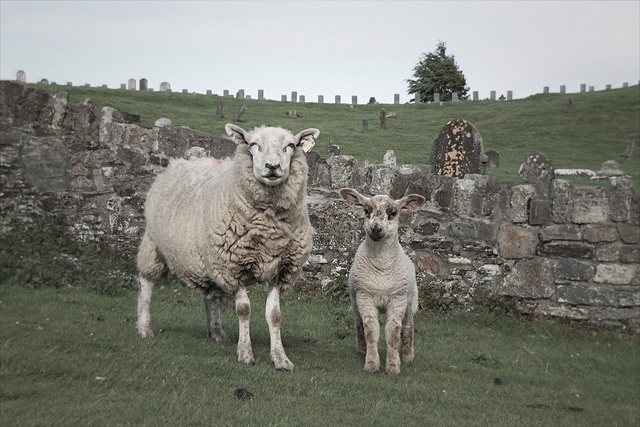Describe the objects in this image and their specific colors. I can see sheep in darkgray, gray, lightgray, and black tones and sheep in darkgray and gray tones in this image. 